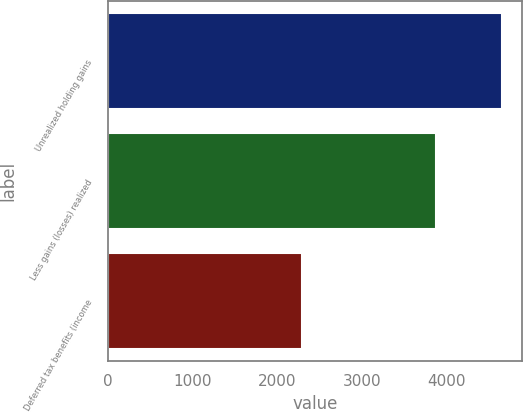Convert chart. <chart><loc_0><loc_0><loc_500><loc_500><bar_chart><fcel>Unrealized holding gains<fcel>Less gains (losses) realized<fcel>Deferred tax benefits (income<nl><fcel>4657.4<fcel>3870<fcel>2295<nl></chart> 